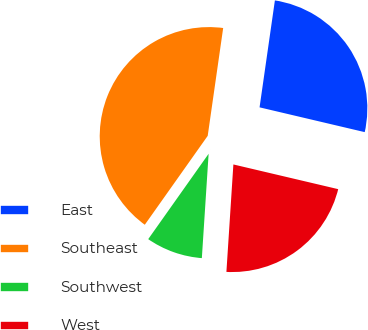Convert chart to OTSL. <chart><loc_0><loc_0><loc_500><loc_500><pie_chart><fcel>East<fcel>Southeast<fcel>Southwest<fcel>West<nl><fcel>26.42%<fcel>42.47%<fcel>8.77%<fcel>22.35%<nl></chart> 